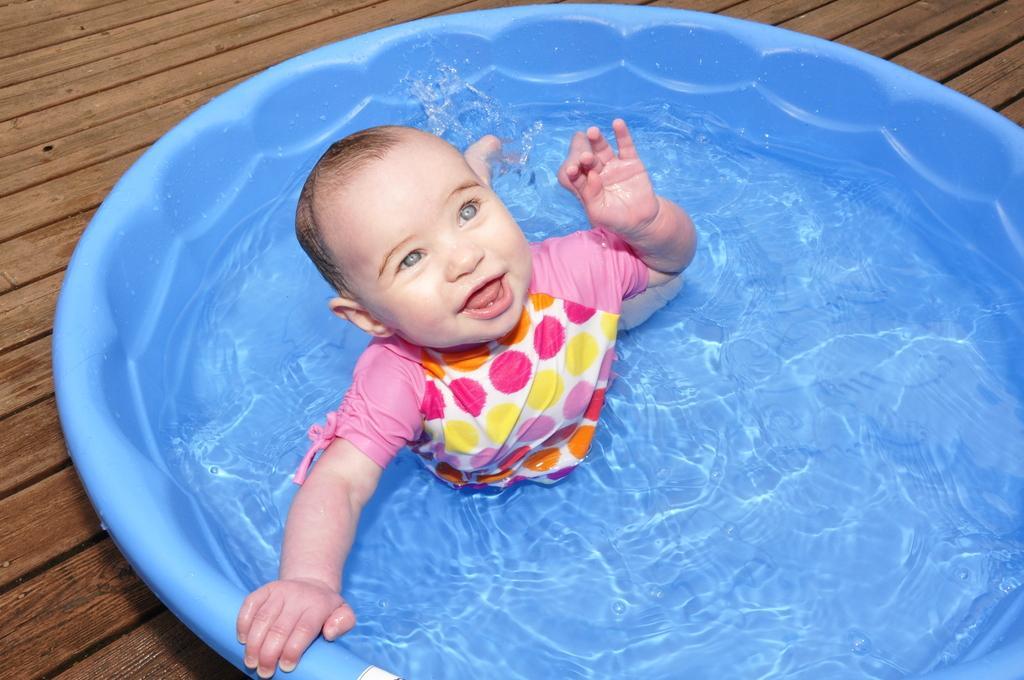Could you give a brief overview of what you see in this image? In this image a baby is in the tub having water. Tub is kept on the wooden floor. 